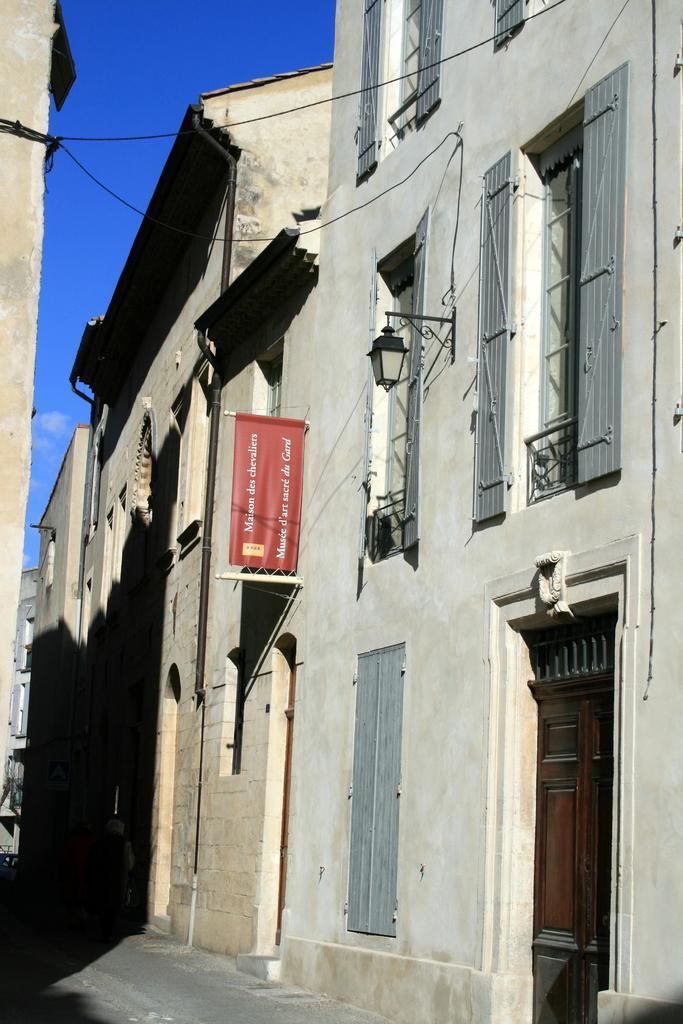Could you give a brief overview of what you see in this image? In this image we can see a few buildings, there is a light, banner and wires attached to the building and sky in the background. 